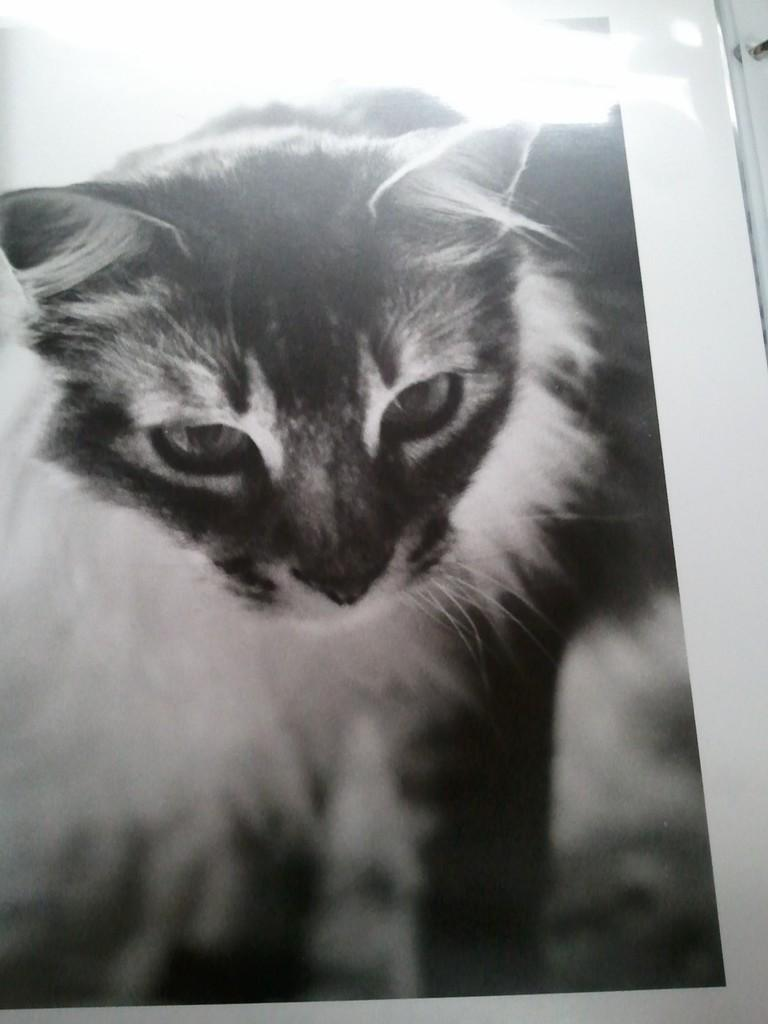What is the color scheme of the image? The image is black and white. What object can be seen in the image? There is a paper in the image. What is depicted on the paper? There is a cat depicted on the paper. What type of island can be seen in the image? There is no island present in the image; it features a black and white paper with a cat depicted on it. 